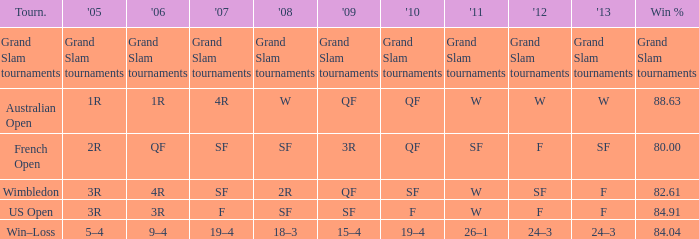Which Tournament has a 2007 of 19–4? Win–Loss. 